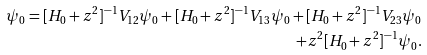Convert formula to latex. <formula><loc_0><loc_0><loc_500><loc_500>\psi _ { 0 } = [ H _ { 0 } + z ^ { 2 } ] ^ { - 1 } V _ { 1 2 } \psi _ { 0 } + [ H _ { 0 } + z ^ { 2 } ] ^ { - 1 } V _ { 1 3 } \psi _ { 0 } + [ H _ { 0 } + z ^ { 2 } ] ^ { - 1 } V _ { 2 3 } \psi _ { 0 } \\ + z ^ { 2 } [ H _ { 0 } + z ^ { 2 } ] ^ { - 1 } \psi _ { 0 } .</formula> 